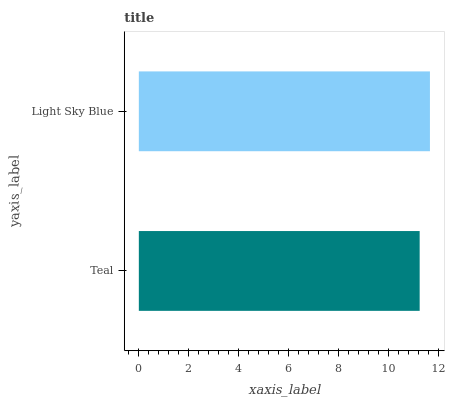Is Teal the minimum?
Answer yes or no. Yes. Is Light Sky Blue the maximum?
Answer yes or no. Yes. Is Light Sky Blue the minimum?
Answer yes or no. No. Is Light Sky Blue greater than Teal?
Answer yes or no. Yes. Is Teal less than Light Sky Blue?
Answer yes or no. Yes. Is Teal greater than Light Sky Blue?
Answer yes or no. No. Is Light Sky Blue less than Teal?
Answer yes or no. No. Is Light Sky Blue the high median?
Answer yes or no. Yes. Is Teal the low median?
Answer yes or no. Yes. Is Teal the high median?
Answer yes or no. No. Is Light Sky Blue the low median?
Answer yes or no. No. 